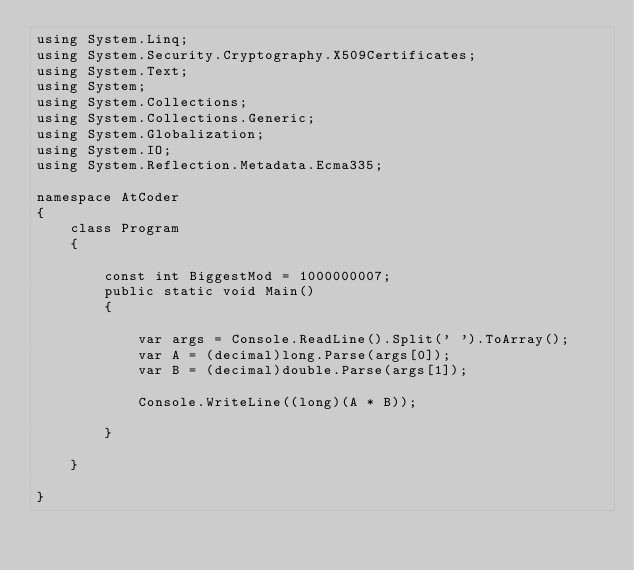<code> <loc_0><loc_0><loc_500><loc_500><_C#_>using System.Linq;
using System.Security.Cryptography.X509Certificates;
using System.Text;
using System;
using System.Collections;
using System.Collections.Generic;
using System.Globalization;
using System.IO;
using System.Reflection.Metadata.Ecma335;

namespace AtCoder
{
    class Program
    {

        const int BiggestMod = 1000000007;
        public static void Main()
        {

            var args = Console.ReadLine().Split(' ').ToArray();
            var A = (decimal)long.Parse(args[0]);
            var B = (decimal)double.Parse(args[1]);

            Console.WriteLine((long)(A * B));

        }

    }

}
</code> 